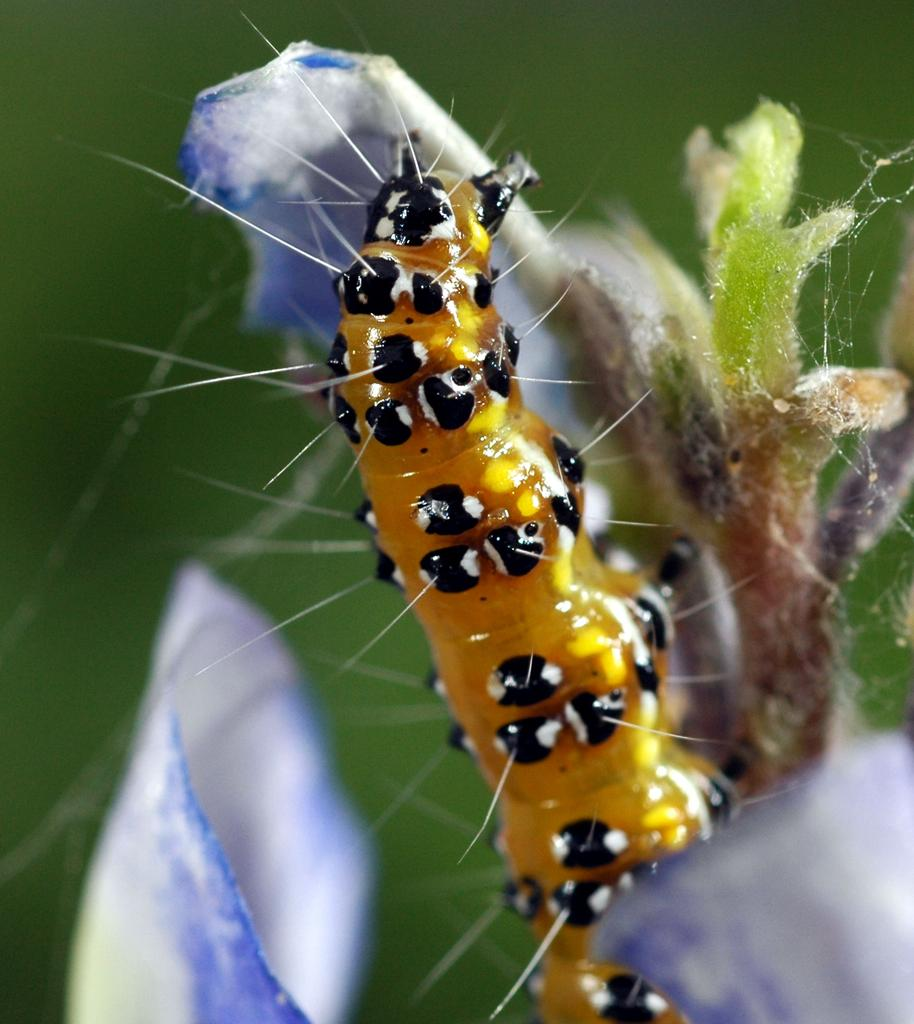What is on the plant in the image? There is a caterpillar on a plant in the image. What type of plant is it? The plant has flowers. Can you describe the background of the image? The background of the image is blurry. How many nuts can be seen hanging from the jellyfish in the image? There are no jellyfish or nuts present in the image. 